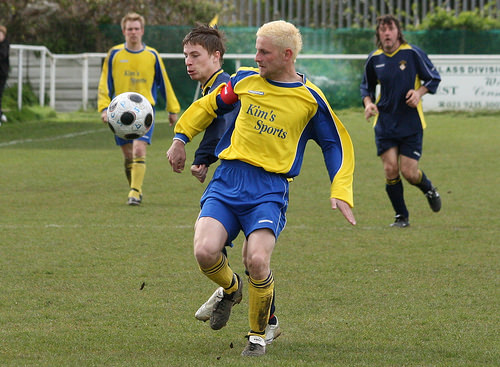<image>
Can you confirm if the ball is to the left of the player? Yes. From this viewpoint, the ball is positioned to the left side relative to the player. Is the football above the ground? Yes. The football is positioned above the ground in the vertical space, higher up in the scene. 